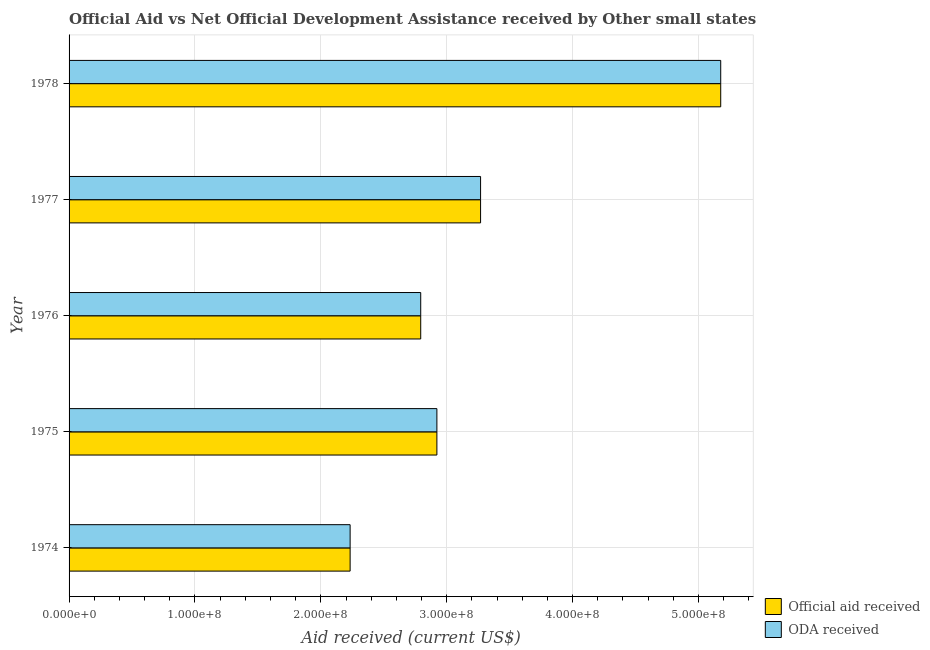Are the number of bars per tick equal to the number of legend labels?
Make the answer very short. Yes. Are the number of bars on each tick of the Y-axis equal?
Ensure brevity in your answer.  Yes. What is the label of the 3rd group of bars from the top?
Your answer should be very brief. 1976. What is the official aid received in 1975?
Offer a terse response. 2.92e+08. Across all years, what is the maximum oda received?
Give a very brief answer. 5.18e+08. Across all years, what is the minimum official aid received?
Give a very brief answer. 2.23e+08. In which year was the oda received maximum?
Your answer should be very brief. 1978. In which year was the oda received minimum?
Your response must be concise. 1974. What is the total oda received in the graph?
Keep it short and to the point. 1.64e+09. What is the difference between the official aid received in 1974 and that in 1975?
Make the answer very short. -6.89e+07. What is the difference between the official aid received in 1976 and the oda received in 1974?
Provide a succinct answer. 5.61e+07. What is the average oda received per year?
Offer a very short reply. 3.28e+08. What is the ratio of the official aid received in 1975 to that in 1978?
Make the answer very short. 0.56. Is the oda received in 1977 less than that in 1978?
Offer a very short reply. Yes. What is the difference between the highest and the second highest oda received?
Your answer should be very brief. 1.91e+08. What is the difference between the highest and the lowest official aid received?
Your answer should be compact. 2.94e+08. What does the 1st bar from the top in 1974 represents?
Your response must be concise. ODA received. What does the 2nd bar from the bottom in 1977 represents?
Offer a very short reply. ODA received. How many years are there in the graph?
Your answer should be compact. 5. Are the values on the major ticks of X-axis written in scientific E-notation?
Provide a succinct answer. Yes. Does the graph contain any zero values?
Keep it short and to the point. No. Does the graph contain grids?
Provide a short and direct response. Yes. Where does the legend appear in the graph?
Your response must be concise. Bottom right. How many legend labels are there?
Make the answer very short. 2. How are the legend labels stacked?
Keep it short and to the point. Vertical. What is the title of the graph?
Provide a succinct answer. Official Aid vs Net Official Development Assistance received by Other small states . What is the label or title of the X-axis?
Give a very brief answer. Aid received (current US$). What is the Aid received (current US$) in Official aid received in 1974?
Ensure brevity in your answer.  2.23e+08. What is the Aid received (current US$) of ODA received in 1974?
Give a very brief answer. 2.23e+08. What is the Aid received (current US$) of Official aid received in 1975?
Make the answer very short. 2.92e+08. What is the Aid received (current US$) in ODA received in 1975?
Offer a terse response. 2.92e+08. What is the Aid received (current US$) in Official aid received in 1976?
Your response must be concise. 2.79e+08. What is the Aid received (current US$) in ODA received in 1976?
Your answer should be very brief. 2.79e+08. What is the Aid received (current US$) of Official aid received in 1977?
Offer a terse response. 3.27e+08. What is the Aid received (current US$) in ODA received in 1977?
Make the answer very short. 3.27e+08. What is the Aid received (current US$) in Official aid received in 1978?
Give a very brief answer. 5.18e+08. What is the Aid received (current US$) in ODA received in 1978?
Keep it short and to the point. 5.18e+08. Across all years, what is the maximum Aid received (current US$) of Official aid received?
Ensure brevity in your answer.  5.18e+08. Across all years, what is the maximum Aid received (current US$) of ODA received?
Your answer should be compact. 5.18e+08. Across all years, what is the minimum Aid received (current US$) of Official aid received?
Your answer should be compact. 2.23e+08. Across all years, what is the minimum Aid received (current US$) of ODA received?
Ensure brevity in your answer.  2.23e+08. What is the total Aid received (current US$) in Official aid received in the graph?
Provide a short and direct response. 1.64e+09. What is the total Aid received (current US$) in ODA received in the graph?
Offer a terse response. 1.64e+09. What is the difference between the Aid received (current US$) of Official aid received in 1974 and that in 1975?
Offer a terse response. -6.89e+07. What is the difference between the Aid received (current US$) in ODA received in 1974 and that in 1975?
Your response must be concise. -6.89e+07. What is the difference between the Aid received (current US$) in Official aid received in 1974 and that in 1976?
Make the answer very short. -5.61e+07. What is the difference between the Aid received (current US$) of ODA received in 1974 and that in 1976?
Ensure brevity in your answer.  -5.61e+07. What is the difference between the Aid received (current US$) of Official aid received in 1974 and that in 1977?
Your answer should be compact. -1.04e+08. What is the difference between the Aid received (current US$) in ODA received in 1974 and that in 1977?
Make the answer very short. -1.04e+08. What is the difference between the Aid received (current US$) of Official aid received in 1974 and that in 1978?
Ensure brevity in your answer.  -2.94e+08. What is the difference between the Aid received (current US$) of ODA received in 1974 and that in 1978?
Your answer should be compact. -2.94e+08. What is the difference between the Aid received (current US$) of Official aid received in 1975 and that in 1976?
Provide a short and direct response. 1.28e+07. What is the difference between the Aid received (current US$) in ODA received in 1975 and that in 1976?
Your answer should be very brief. 1.28e+07. What is the difference between the Aid received (current US$) of Official aid received in 1975 and that in 1977?
Provide a short and direct response. -3.47e+07. What is the difference between the Aid received (current US$) in ODA received in 1975 and that in 1977?
Keep it short and to the point. -3.47e+07. What is the difference between the Aid received (current US$) in Official aid received in 1975 and that in 1978?
Your answer should be compact. -2.25e+08. What is the difference between the Aid received (current US$) of ODA received in 1975 and that in 1978?
Give a very brief answer. -2.25e+08. What is the difference between the Aid received (current US$) of Official aid received in 1976 and that in 1977?
Offer a very short reply. -4.76e+07. What is the difference between the Aid received (current US$) in ODA received in 1976 and that in 1977?
Provide a short and direct response. -4.76e+07. What is the difference between the Aid received (current US$) in Official aid received in 1976 and that in 1978?
Offer a terse response. -2.38e+08. What is the difference between the Aid received (current US$) in ODA received in 1976 and that in 1978?
Keep it short and to the point. -2.38e+08. What is the difference between the Aid received (current US$) of Official aid received in 1977 and that in 1978?
Give a very brief answer. -1.91e+08. What is the difference between the Aid received (current US$) of ODA received in 1977 and that in 1978?
Keep it short and to the point. -1.91e+08. What is the difference between the Aid received (current US$) in Official aid received in 1974 and the Aid received (current US$) in ODA received in 1975?
Your answer should be compact. -6.89e+07. What is the difference between the Aid received (current US$) of Official aid received in 1974 and the Aid received (current US$) of ODA received in 1976?
Give a very brief answer. -5.61e+07. What is the difference between the Aid received (current US$) of Official aid received in 1974 and the Aid received (current US$) of ODA received in 1977?
Keep it short and to the point. -1.04e+08. What is the difference between the Aid received (current US$) in Official aid received in 1974 and the Aid received (current US$) in ODA received in 1978?
Your answer should be very brief. -2.94e+08. What is the difference between the Aid received (current US$) of Official aid received in 1975 and the Aid received (current US$) of ODA received in 1976?
Provide a succinct answer. 1.28e+07. What is the difference between the Aid received (current US$) of Official aid received in 1975 and the Aid received (current US$) of ODA received in 1977?
Ensure brevity in your answer.  -3.47e+07. What is the difference between the Aid received (current US$) of Official aid received in 1975 and the Aid received (current US$) of ODA received in 1978?
Keep it short and to the point. -2.25e+08. What is the difference between the Aid received (current US$) in Official aid received in 1976 and the Aid received (current US$) in ODA received in 1977?
Your response must be concise. -4.76e+07. What is the difference between the Aid received (current US$) of Official aid received in 1976 and the Aid received (current US$) of ODA received in 1978?
Your response must be concise. -2.38e+08. What is the difference between the Aid received (current US$) of Official aid received in 1977 and the Aid received (current US$) of ODA received in 1978?
Provide a short and direct response. -1.91e+08. What is the average Aid received (current US$) of Official aid received per year?
Keep it short and to the point. 3.28e+08. What is the average Aid received (current US$) of ODA received per year?
Provide a succinct answer. 3.28e+08. In the year 1975, what is the difference between the Aid received (current US$) of Official aid received and Aid received (current US$) of ODA received?
Ensure brevity in your answer.  0. What is the ratio of the Aid received (current US$) of Official aid received in 1974 to that in 1975?
Give a very brief answer. 0.76. What is the ratio of the Aid received (current US$) in ODA received in 1974 to that in 1975?
Your response must be concise. 0.76. What is the ratio of the Aid received (current US$) of Official aid received in 1974 to that in 1976?
Ensure brevity in your answer.  0.8. What is the ratio of the Aid received (current US$) in ODA received in 1974 to that in 1976?
Keep it short and to the point. 0.8. What is the ratio of the Aid received (current US$) in Official aid received in 1974 to that in 1977?
Offer a terse response. 0.68. What is the ratio of the Aid received (current US$) of ODA received in 1974 to that in 1977?
Ensure brevity in your answer.  0.68. What is the ratio of the Aid received (current US$) in Official aid received in 1974 to that in 1978?
Provide a succinct answer. 0.43. What is the ratio of the Aid received (current US$) of ODA received in 1974 to that in 1978?
Offer a terse response. 0.43. What is the ratio of the Aid received (current US$) of Official aid received in 1975 to that in 1976?
Your answer should be compact. 1.05. What is the ratio of the Aid received (current US$) of ODA received in 1975 to that in 1976?
Make the answer very short. 1.05. What is the ratio of the Aid received (current US$) of Official aid received in 1975 to that in 1977?
Offer a very short reply. 0.89. What is the ratio of the Aid received (current US$) in ODA received in 1975 to that in 1977?
Your answer should be compact. 0.89. What is the ratio of the Aid received (current US$) of Official aid received in 1975 to that in 1978?
Your answer should be compact. 0.56. What is the ratio of the Aid received (current US$) of ODA received in 1975 to that in 1978?
Offer a very short reply. 0.56. What is the ratio of the Aid received (current US$) of Official aid received in 1976 to that in 1977?
Your answer should be compact. 0.85. What is the ratio of the Aid received (current US$) of ODA received in 1976 to that in 1977?
Provide a succinct answer. 0.85. What is the ratio of the Aid received (current US$) in Official aid received in 1976 to that in 1978?
Your answer should be very brief. 0.54. What is the ratio of the Aid received (current US$) of ODA received in 1976 to that in 1978?
Your answer should be very brief. 0.54. What is the ratio of the Aid received (current US$) in Official aid received in 1977 to that in 1978?
Keep it short and to the point. 0.63. What is the ratio of the Aid received (current US$) of ODA received in 1977 to that in 1978?
Make the answer very short. 0.63. What is the difference between the highest and the second highest Aid received (current US$) in Official aid received?
Provide a succinct answer. 1.91e+08. What is the difference between the highest and the second highest Aid received (current US$) in ODA received?
Your answer should be very brief. 1.91e+08. What is the difference between the highest and the lowest Aid received (current US$) of Official aid received?
Your answer should be compact. 2.94e+08. What is the difference between the highest and the lowest Aid received (current US$) in ODA received?
Offer a very short reply. 2.94e+08. 